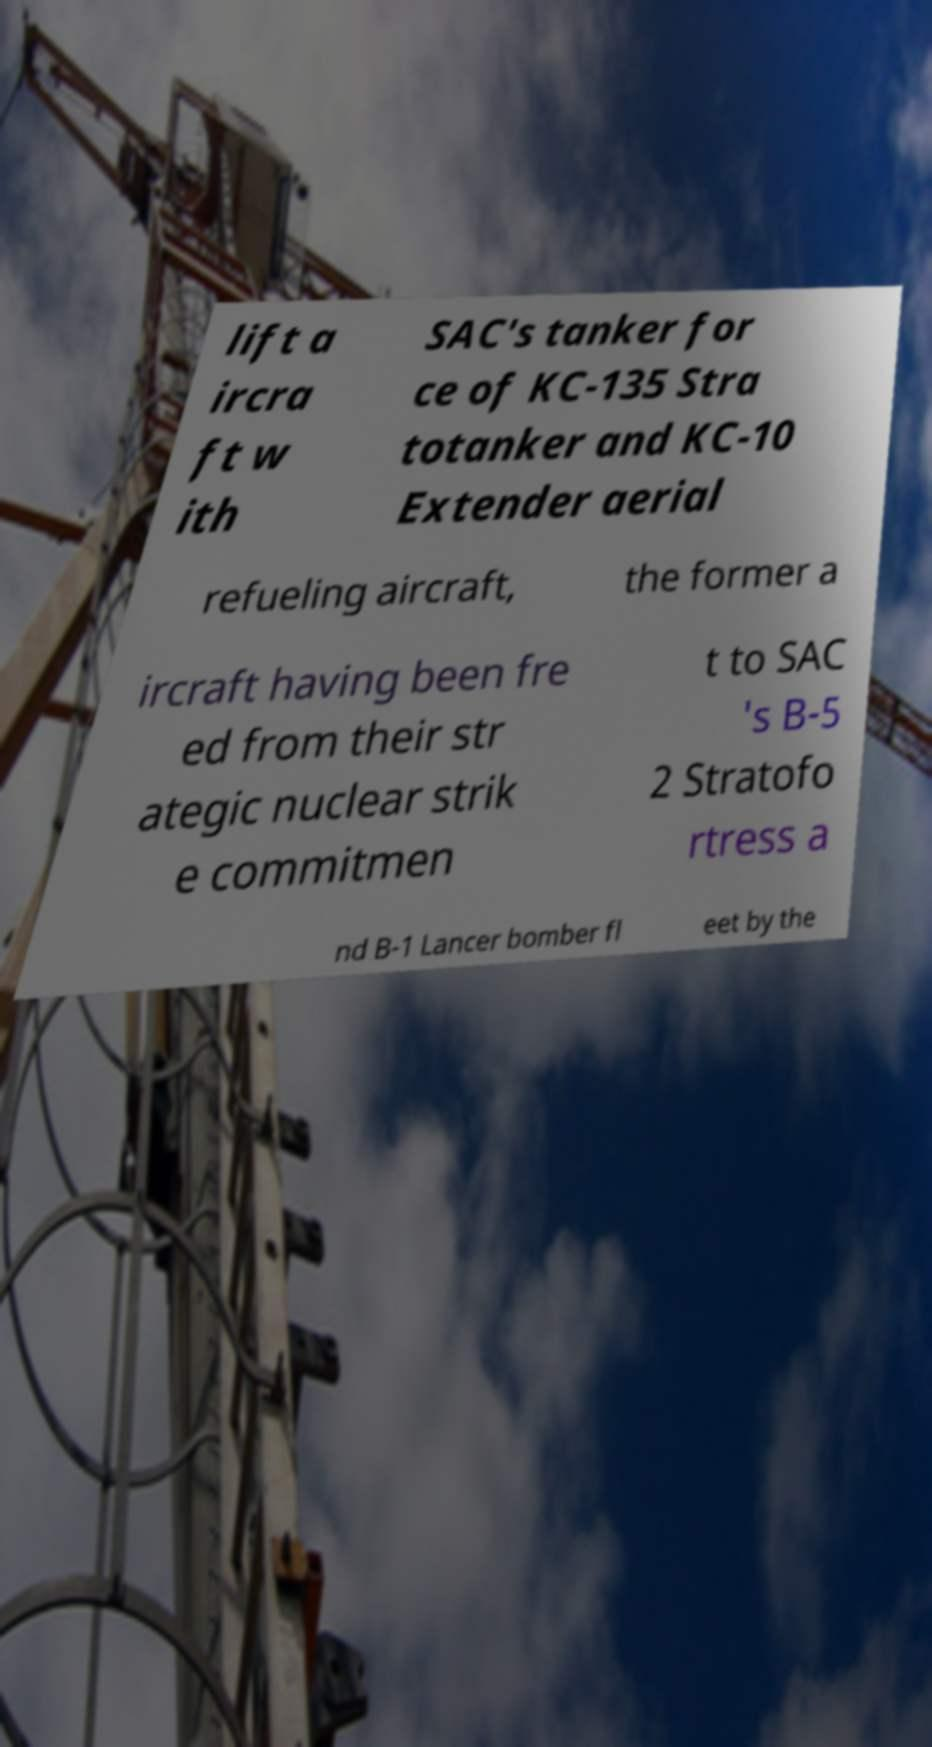What messages or text are displayed in this image? I need them in a readable, typed format. lift a ircra ft w ith SAC's tanker for ce of KC-135 Stra totanker and KC-10 Extender aerial refueling aircraft, the former a ircraft having been fre ed from their str ategic nuclear strik e commitmen t to SAC 's B-5 2 Stratofo rtress a nd B-1 Lancer bomber fl eet by the 